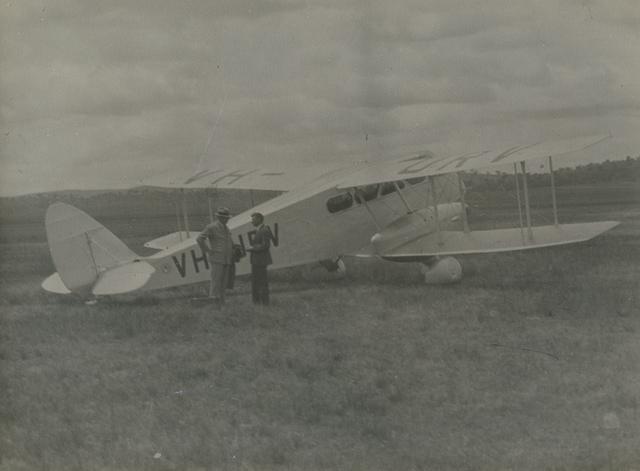Is this a recent photo?
Short answer required. No. Is here an army base?
Short answer required. No. How man men are present?
Quick response, please. 2. Is this a single wing plane?
Be succinct. No. 